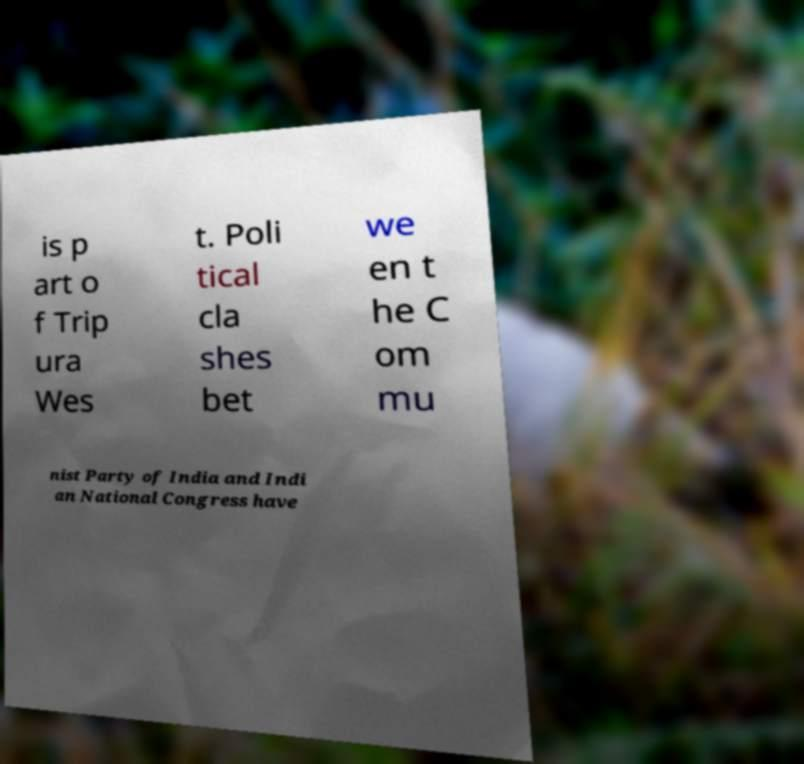Can you accurately transcribe the text from the provided image for me? is p art o f Trip ura Wes t. Poli tical cla shes bet we en t he C om mu nist Party of India and Indi an National Congress have 